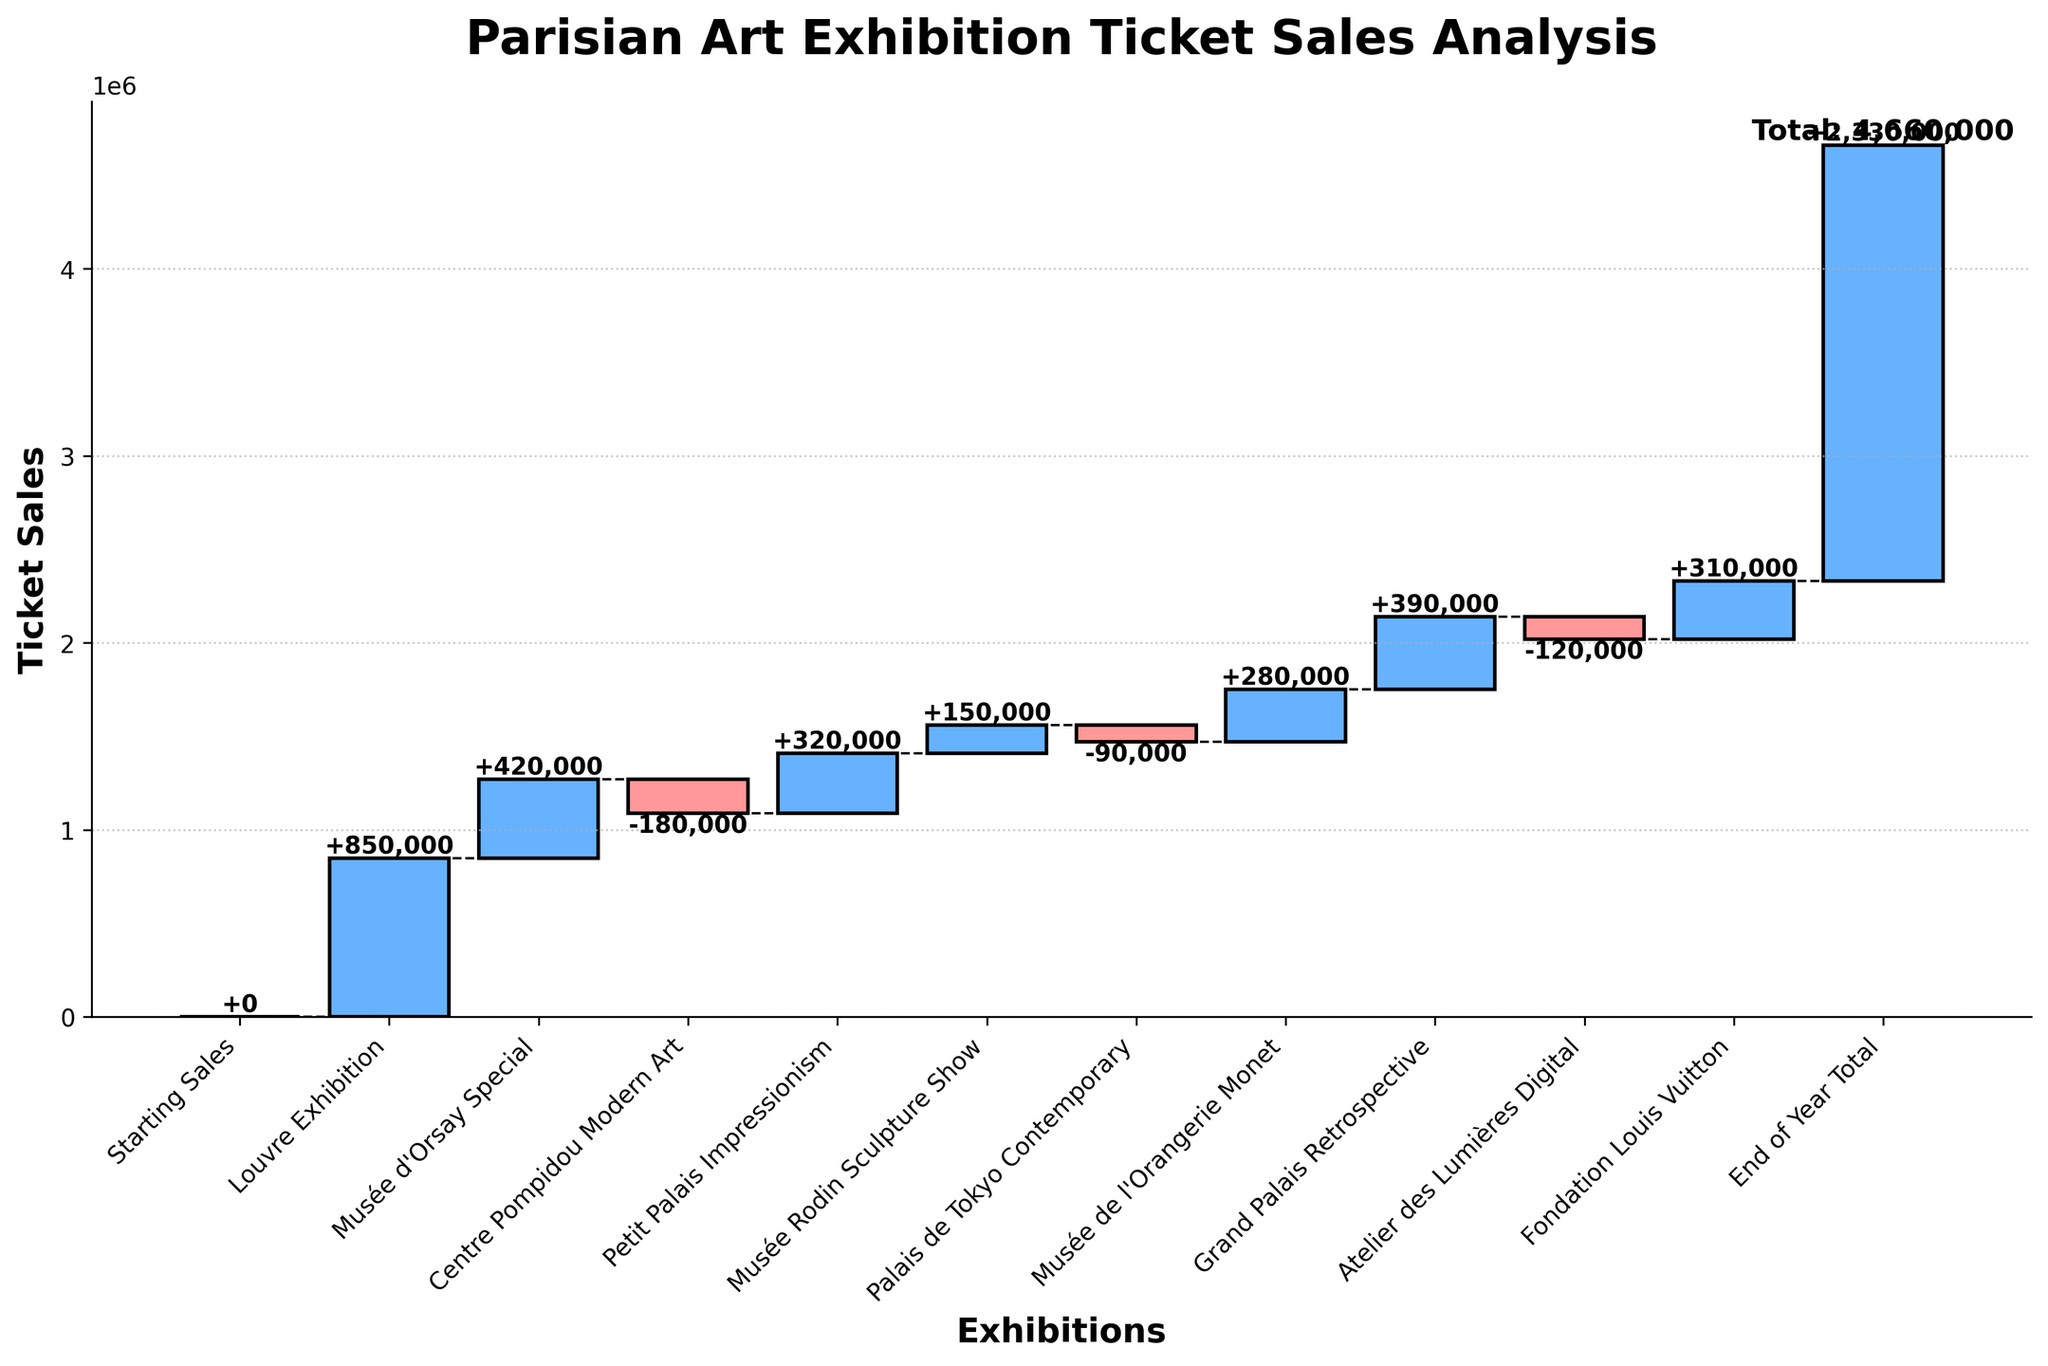What's the title of the chart? The title of the chart is usually located at the top and provides the main idea or subject of the visualization. In this case, it states the purpose of the chart.
Answer: Parisian Art Exhibition Ticket Sales Analysis How many exhibitions had negative ticket sales? By examining the colors of the bars, negative values are indicated by a distinct color (e.g., red). Count these bars to find the results. The negative values are: Centre Pompidou Modern Art, Palais de Tokyo Contemporary, and Atelier des Lumières Digital.
Answer: 3 Which exhibition had the highest ticket sales? Look at the bars with the highest positive values and compare the heights. The Louvre Exhibition shows the tallest bar in the positive direction.
Answer: Louvre Exhibition What is the overall trend in ticket sales throughout the year? Analyze the cumulative values connected by the dashed lines. Generally observe if the cumulative values increase, decrease, or fluctuate. Here, despite some declines, the overall trend is increasing.
Answer: Increasing What is the cumulative ticket sales after the Musée d'Orsay Special? Calculate the cumulative sum up to and including the Musée d'Orsay Special. The first value is Louvre (850000) and the next value is Musée d'Orsay Special (420000), so cumulative is 850000 + 420000 (1270000).
Answer: 1,270,000 By how much did the ticket sales change from Centre Pompidou Modern Art to Petit Palais Impressionism? Find the values for both exhibitions. Centre Pompidou Modern Art is -180000 and Petit Palais Impressionism is 320000. The difference is computed as 320000 - (-180000) = 320000 + 180000.
Answer: 500,000 What is the combined ticket sales of the exhibitions that had a positive contribution? Add the values of all exhibitions with positive ticket sales. Louvre (850000), Musée d'Orsay Special (420000), Petit Palais Impressionism (320000), Musée Rodin Sculpture Show (150000), Musée de l'Orangerie Monet (280000), Grand Palais Retrospective (390000), Fondation Louis Vuitton (310000). Sum these values: 850000 + 420000 + 320000 + 150000 + 280000 + 390000 + 310000.
Answer: 2,720,000 What is the difference in ticket sales between the Musée d'Orsay Special and Centre Pompidou Modern Art? Subtract the values of Centre Pompidou Modern Art from Musée d'Orsay Special. The values are 420000 and -180000 respectively, so 420000 - (-180000) = 420000 + 180000.
Answer: 600,000 What is the final total ticket sales at the end of the year? The final cumulative value listed at the end of the chart, marked with the label "End of Year Total."
Answer: 2,330,000 